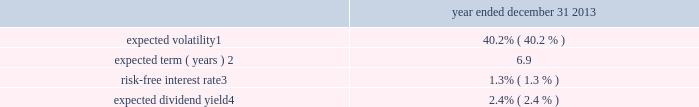Notes to consolidated financial statements 2013 ( continued ) ( amounts in millions , except per share amounts ) assumptions can materially affect the estimate of fair value , and our results of operations could be materially impacted .
There were no stock options granted during the years ended december 31 , 2015 and 2014 .
The weighted-average grant-date fair value per option during the year ended december 31 , 2013 was $ 4.14 .
The fair value of each option grant has been estimated with the following weighted-average assumptions. .
Expected volatility 1 .
40.2% ( 40.2 % ) expected term ( years ) 2 .
6.9 risk-free interest rate 3 .
1.3% ( 1.3 % ) expected dividend yield 4 .
2.4% ( 2.4 % ) 1 the expected volatility used to estimate the fair value of stock options awarded is based on a blend of : ( i ) historical volatility of our common stock for periods equal to the expected term of our stock options and ( ii ) implied volatility of tradable forward put and call options to purchase and sell shares of our common stock .
2 the estimate of our expected term is based on the average of : ( i ) an assumption that all outstanding options are exercised upon achieving their full vesting date and ( ii ) an assumption that all outstanding options will be exercised at the midpoint between the current date ( i.e. , the date awards have ratably vested through ) and their full contractual term .
In determining the estimate , we considered several factors , including the historical option exercise behavior of our employees and the terms and vesting periods of the options .
3 the risk-free interest rate is determined using the implied yield currently available for zero-coupon u.s .
Government issuers with a remaining term equal to the expected term of the options .
4 the expected dividend yield was calculated based on an annualized dividend of $ 0.30 per share in 2013 .
Stock-based compensation we grant other stock-based compensation awards such as stock-settled awards , cash-settled awards and performance- based awards ( settled in cash or shares ) to certain key employees .
The number of shares or units received by an employee for performance-based awards depends on company performance against specific performance targets and could range from 0% ( 0 % ) to 300% ( 300 % ) of the target amount of shares originally granted .
Incentive awards are subject to certain restrictions and vesting requirements as determined by the compensation committee .
The fair value of the shares on the grant date is amortized over the vesting period , which is generally three years .
Upon completion of the vesting period for cash-settled awards , the grantee is entitled to receive a payment in cash based on the fair market value of the corresponding number of shares of common stock .
No monetary consideration is paid by a recipient for any incentive award .
The fair value of cash-settled awards is adjusted each quarter based on our share price .
The holders of stock-settled awards have absolute ownership interest in the underlying shares of common stock prior to vesting , which includes the right to vote and receive dividends .
Dividends declared on common stock are accrued during the vesting period and paid when the award vests .
The holders of cash-settled and performance-based awards have no ownership interest in the underlying shares of common stock until the awards vest and the shares of common stock are issued. .
How many total stock options were granted in 2014 and 2015 combined? 
Computations: (0 + 0)
Answer: 0.0. 